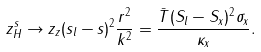Convert formula to latex. <formula><loc_0><loc_0><loc_500><loc_500>z _ { H } ^ { s } \rightarrow z _ { z } ( s _ { l } - s ) ^ { 2 } \frac { r ^ { 2 } } { k ^ { 2 } } = \frac { \bar { T } ( S _ { l } - S _ { x } ) ^ { 2 } \sigma _ { x } } { \kappa _ { x } } .</formula> 